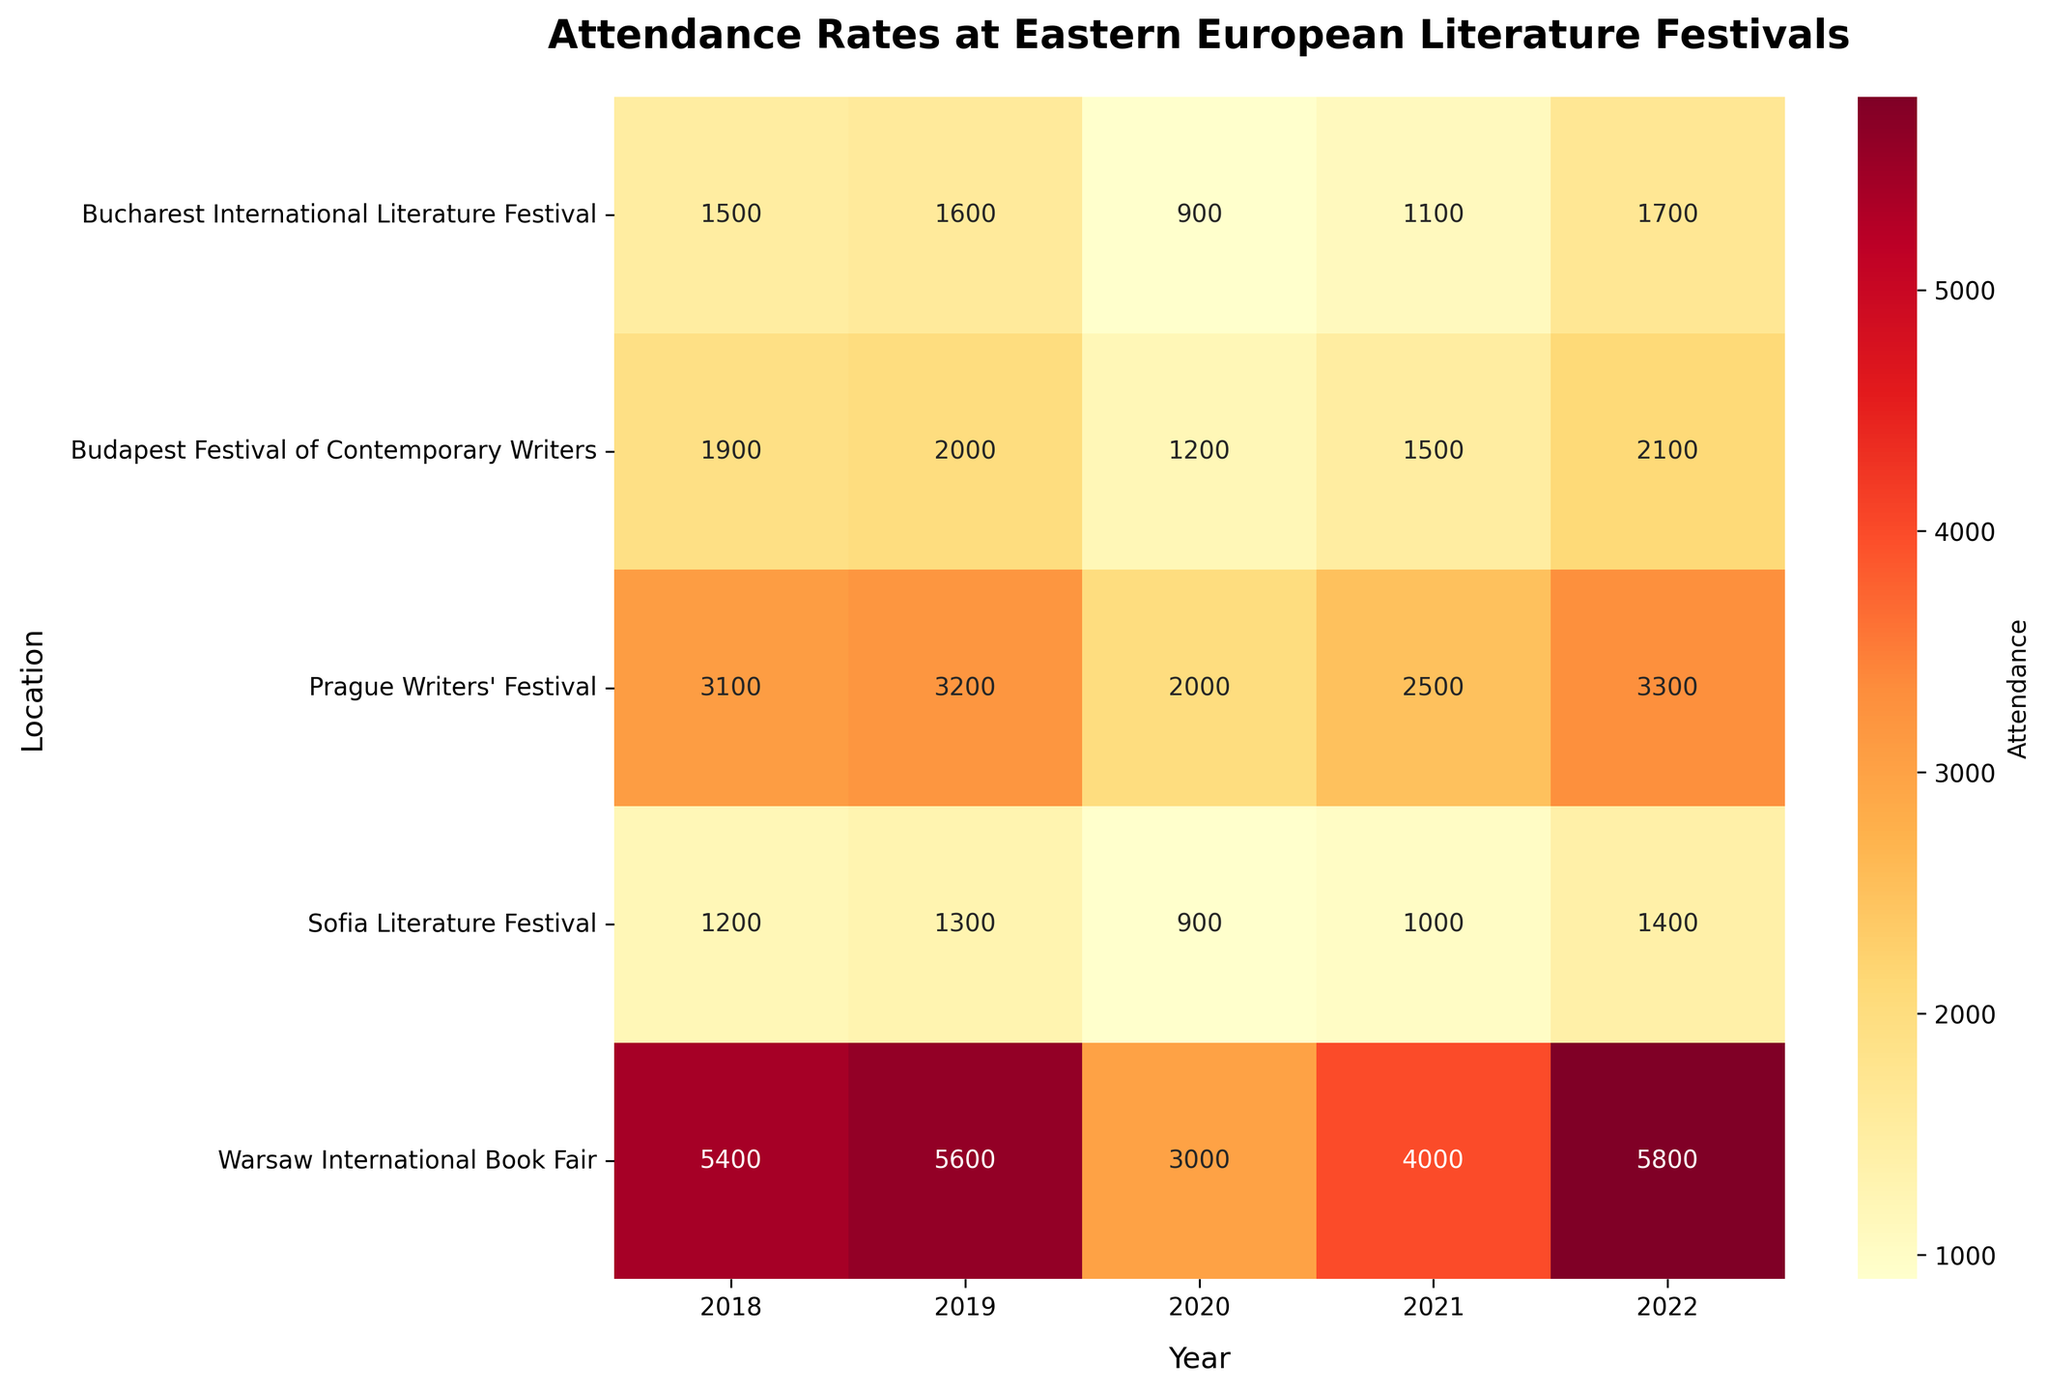What is the title of the heatmap? The title is usually located at the top of the plot and is clearly written in bold. It helps viewers to understand the context of the data being visualized. For this particular heatmap, the title is "Attendance Rates at Eastern European Literature Festivals".
Answer: Attendance Rates at Eastern European Literature Festivals Which location had the highest attendance in 2022? By looking along the column for the year 2022 and identifying the highest value, we see that the "Warsaw International Book Fair" had the highest attendance at 5800.
Answer: Warsaw International Book Fair How did the attendance rates at the Sofia Literature Festival change from 2018 to 2022? By comparing the attendance values for Sofia Literature Festival across the years 2018 to 2022, we see that it started at 1200 in 2018 and varied over the years: 1300 in 2019, 900 in 2020, 1000 in 2021, and 1400 in 2022. This shows fluctuations with an overall increase to 1400 in 2022.
Answer: Increased to 1400 Can you identify the year with the lowest attendance rate for the Budapest Festival of Contemporary Writers? By finding the minimum attendance value for the Budapest Festival of Contemporary Writers across all the given years, 2020 has the lowest attendance at 1200.
Answer: 2020 Which festival showed the greatest increase in attendance from 2021 to 2022? By calculating the difference in attendance values between 2021 and 2022 for each festival, the Warsaw International Book Fair showed an increase from 4000 to 5800, which is the largest increase of 1800.
Answer: Warsaw International Book Fair In which year was the attendance at the Bucharest International Literature Festival highest? By examining the attendance values for the Bucharest International Literature Festival across different years, 2022 had the highest attendance at 1700.
Answer: 2022 What is the average attendance at the Prague Writers' Festival across all years shown in the heatmap? Summing the attendance values for the Prague Writers' Festival (3100, 3200, 2000, 2500, 3300) and dividing by the number of years (5) gives the average attendance: (3100 + 3200 + 2000 + 2500 + 3300) / 5 = 2820.
Answer: 2820 Which year had the lowest total attendance across all festivals? By summing the attendance of all festivals for each year and comparing, 2020 has the lowest total attendance: Sofia (900) + Warsaw (3000) + Prague (2000) + Bucharest (900) + Budapest (1200) = 8000.
Answer: 2020 Which festival had declining attendance every year from 2018 to 2020? By examining the attendance values for each festival year by year, the Sofia Literature Festival shows a decline: 1200 (2018), 1300 (2019), 900 (2020).
Answer: Sofia Literature Festival 